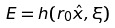<formula> <loc_0><loc_0><loc_500><loc_500>E = h { \left ( r _ { 0 } \hat { x } , \xi \right ) }</formula> 